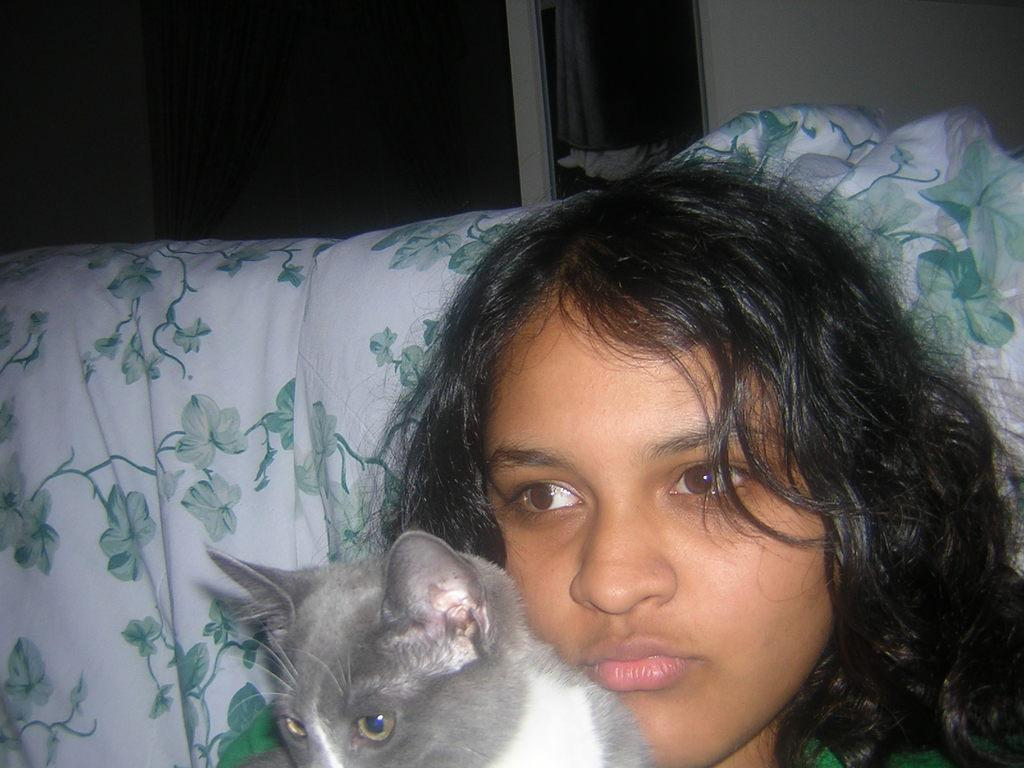Who is present in the image? There is a girl in the image. What is the girl holding? The girl is holding a cat. What can be seen in the background of the image? There is a pillow, a curtain associated with a window, a window, and a wall in the background of the image. What type of vest is being distributed to the boats in the image? There are no boats or vests present in the image; it features a girl holding a cat with a background containing a pillow, curtain, window, and wall. 